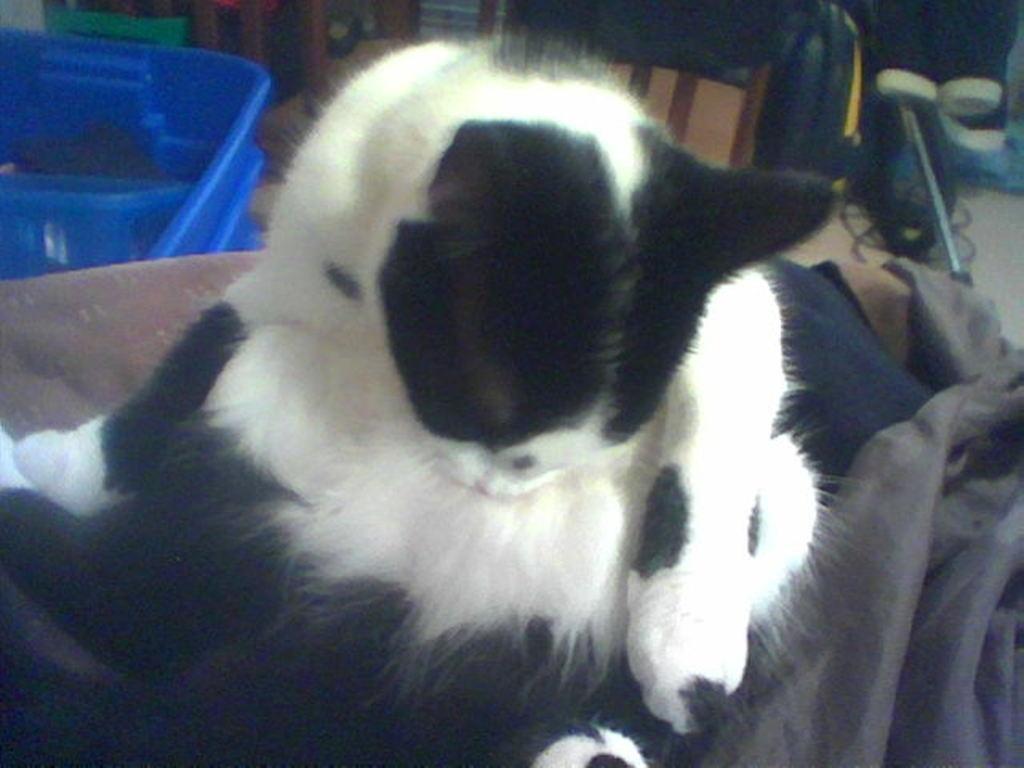Describe this image in one or two sentences. There is a black and white cat. Near to that there is a cloth. On the left side there is a blue color object. In the back there are few items. 